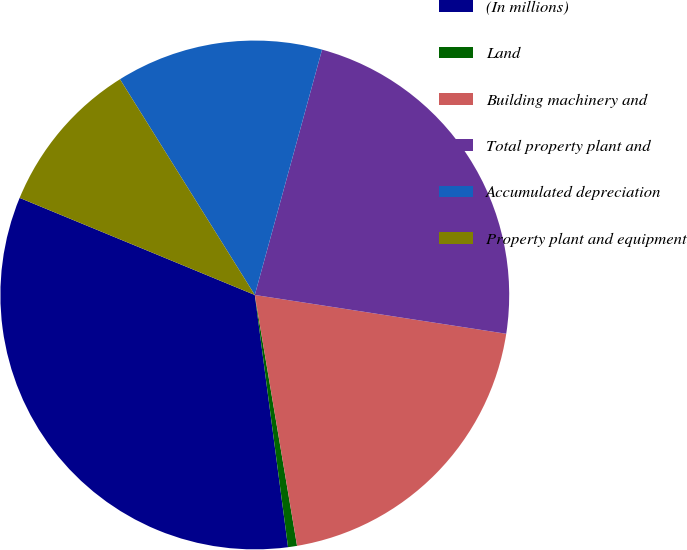Convert chart to OTSL. <chart><loc_0><loc_0><loc_500><loc_500><pie_chart><fcel>(In millions)<fcel>Land<fcel>Building machinery and<fcel>Total property plant and<fcel>Accumulated depreciation<fcel>Property plant and equipment<nl><fcel>33.32%<fcel>0.57%<fcel>19.91%<fcel>23.18%<fcel>13.15%<fcel>9.88%<nl></chart> 